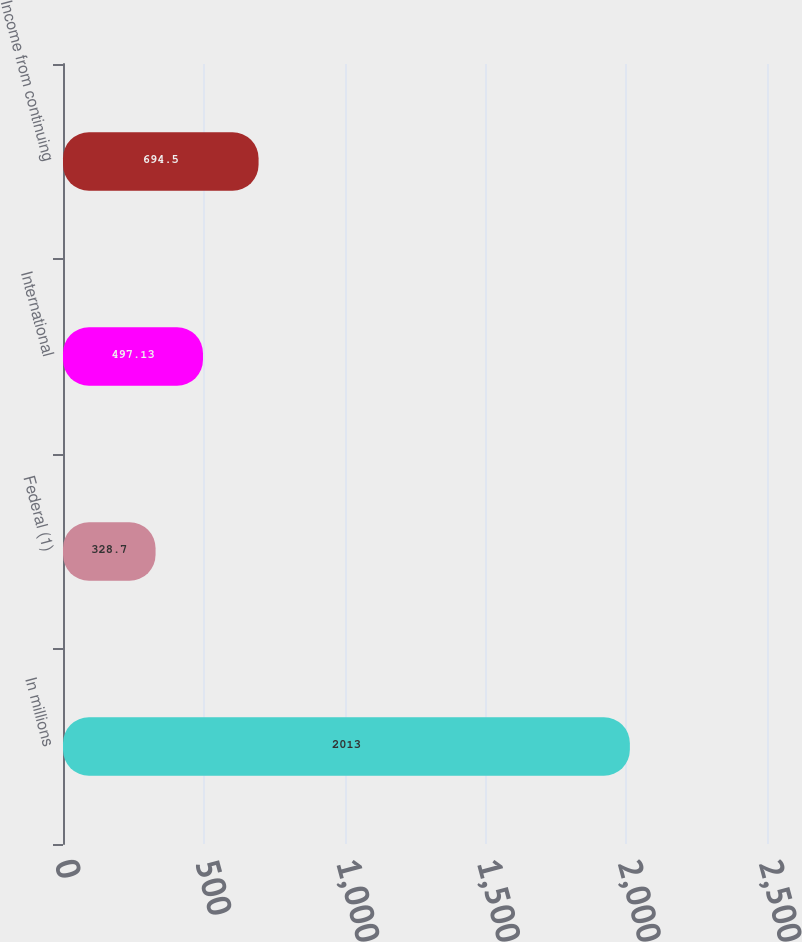<chart> <loc_0><loc_0><loc_500><loc_500><bar_chart><fcel>In millions<fcel>Federal (1)<fcel>International<fcel>Income from continuing<nl><fcel>2013<fcel>328.7<fcel>497.13<fcel>694.5<nl></chart> 